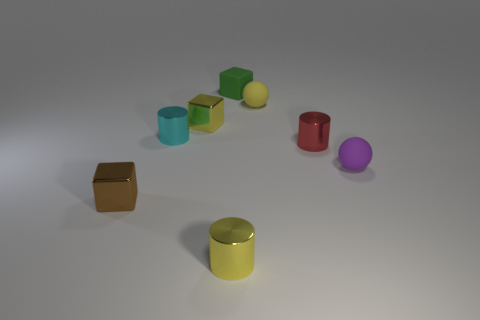What can you infer about the lighting in this scene? The lighting in the image appears to be coming from above, casting soft shadows directly beneath the objects. This type of lighting creates a calm atmosphere and allows the colors of the objects to present softly without harsh contrasts. 